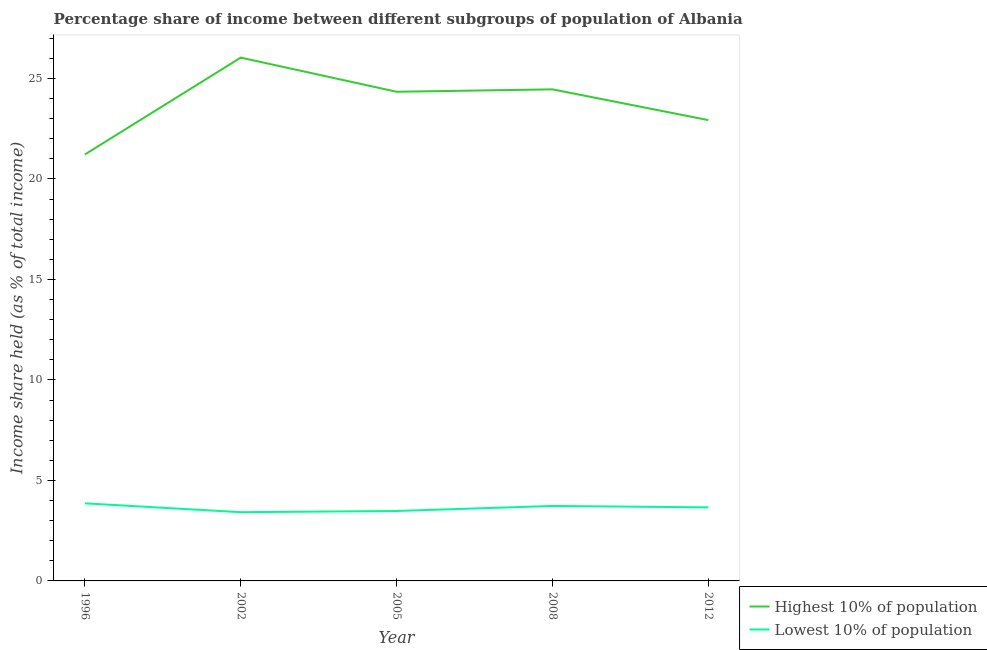How many different coloured lines are there?
Ensure brevity in your answer.  2. Is the number of lines equal to the number of legend labels?
Your response must be concise. Yes. What is the income share held by highest 10% of the population in 1996?
Provide a succinct answer. 21.22. Across all years, what is the maximum income share held by lowest 10% of the population?
Your answer should be very brief. 3.86. Across all years, what is the minimum income share held by highest 10% of the population?
Your answer should be compact. 21.22. What is the total income share held by highest 10% of the population in the graph?
Make the answer very short. 118.99. What is the difference between the income share held by lowest 10% of the population in 1996 and that in 2002?
Your answer should be compact. 0.44. What is the difference between the income share held by highest 10% of the population in 2008 and the income share held by lowest 10% of the population in 2002?
Make the answer very short. 21.04. What is the average income share held by highest 10% of the population per year?
Give a very brief answer. 23.8. In the year 2002, what is the difference between the income share held by highest 10% of the population and income share held by lowest 10% of the population?
Your answer should be very brief. 22.62. What is the ratio of the income share held by lowest 10% of the population in 1996 to that in 2005?
Make the answer very short. 1.11. Is the difference between the income share held by lowest 10% of the population in 1996 and 2012 greater than the difference between the income share held by highest 10% of the population in 1996 and 2012?
Your response must be concise. Yes. What is the difference between the highest and the second highest income share held by highest 10% of the population?
Your response must be concise. 1.58. What is the difference between the highest and the lowest income share held by lowest 10% of the population?
Make the answer very short. 0.44. In how many years, is the income share held by highest 10% of the population greater than the average income share held by highest 10% of the population taken over all years?
Offer a very short reply. 3. Does the income share held by lowest 10% of the population monotonically increase over the years?
Your response must be concise. No. Is the income share held by lowest 10% of the population strictly greater than the income share held by highest 10% of the population over the years?
Your response must be concise. No. How many lines are there?
Provide a short and direct response. 2. How many years are there in the graph?
Offer a very short reply. 5. Does the graph contain any zero values?
Your answer should be compact. No. Does the graph contain grids?
Give a very brief answer. No. How many legend labels are there?
Keep it short and to the point. 2. What is the title of the graph?
Keep it short and to the point. Percentage share of income between different subgroups of population of Albania. Does "Primary school" appear as one of the legend labels in the graph?
Offer a very short reply. No. What is the label or title of the X-axis?
Your answer should be compact. Year. What is the label or title of the Y-axis?
Your answer should be compact. Income share held (as % of total income). What is the Income share held (as % of total income) in Highest 10% of population in 1996?
Offer a very short reply. 21.22. What is the Income share held (as % of total income) in Lowest 10% of population in 1996?
Offer a terse response. 3.86. What is the Income share held (as % of total income) of Highest 10% of population in 2002?
Provide a succinct answer. 26.04. What is the Income share held (as % of total income) of Lowest 10% of population in 2002?
Provide a short and direct response. 3.42. What is the Income share held (as % of total income) of Highest 10% of population in 2005?
Provide a succinct answer. 24.34. What is the Income share held (as % of total income) in Lowest 10% of population in 2005?
Provide a succinct answer. 3.48. What is the Income share held (as % of total income) of Highest 10% of population in 2008?
Provide a succinct answer. 24.46. What is the Income share held (as % of total income) in Lowest 10% of population in 2008?
Give a very brief answer. 3.73. What is the Income share held (as % of total income) in Highest 10% of population in 2012?
Your answer should be compact. 22.93. What is the Income share held (as % of total income) in Lowest 10% of population in 2012?
Keep it short and to the point. 3.66. Across all years, what is the maximum Income share held (as % of total income) in Highest 10% of population?
Your answer should be very brief. 26.04. Across all years, what is the maximum Income share held (as % of total income) of Lowest 10% of population?
Provide a short and direct response. 3.86. Across all years, what is the minimum Income share held (as % of total income) of Highest 10% of population?
Keep it short and to the point. 21.22. Across all years, what is the minimum Income share held (as % of total income) in Lowest 10% of population?
Provide a short and direct response. 3.42. What is the total Income share held (as % of total income) of Highest 10% of population in the graph?
Your response must be concise. 118.99. What is the total Income share held (as % of total income) in Lowest 10% of population in the graph?
Make the answer very short. 18.15. What is the difference between the Income share held (as % of total income) in Highest 10% of population in 1996 and that in 2002?
Make the answer very short. -4.82. What is the difference between the Income share held (as % of total income) of Lowest 10% of population in 1996 and that in 2002?
Provide a succinct answer. 0.44. What is the difference between the Income share held (as % of total income) in Highest 10% of population in 1996 and that in 2005?
Your answer should be very brief. -3.12. What is the difference between the Income share held (as % of total income) of Lowest 10% of population in 1996 and that in 2005?
Make the answer very short. 0.38. What is the difference between the Income share held (as % of total income) of Highest 10% of population in 1996 and that in 2008?
Make the answer very short. -3.24. What is the difference between the Income share held (as % of total income) in Lowest 10% of population in 1996 and that in 2008?
Provide a succinct answer. 0.13. What is the difference between the Income share held (as % of total income) in Highest 10% of population in 1996 and that in 2012?
Offer a terse response. -1.71. What is the difference between the Income share held (as % of total income) of Lowest 10% of population in 1996 and that in 2012?
Provide a succinct answer. 0.2. What is the difference between the Income share held (as % of total income) of Lowest 10% of population in 2002 and that in 2005?
Provide a short and direct response. -0.06. What is the difference between the Income share held (as % of total income) of Highest 10% of population in 2002 and that in 2008?
Your answer should be very brief. 1.58. What is the difference between the Income share held (as % of total income) in Lowest 10% of population in 2002 and that in 2008?
Give a very brief answer. -0.31. What is the difference between the Income share held (as % of total income) of Highest 10% of population in 2002 and that in 2012?
Give a very brief answer. 3.11. What is the difference between the Income share held (as % of total income) in Lowest 10% of population in 2002 and that in 2012?
Make the answer very short. -0.24. What is the difference between the Income share held (as % of total income) in Highest 10% of population in 2005 and that in 2008?
Your answer should be very brief. -0.12. What is the difference between the Income share held (as % of total income) of Highest 10% of population in 2005 and that in 2012?
Offer a terse response. 1.41. What is the difference between the Income share held (as % of total income) in Lowest 10% of population in 2005 and that in 2012?
Give a very brief answer. -0.18. What is the difference between the Income share held (as % of total income) in Highest 10% of population in 2008 and that in 2012?
Provide a short and direct response. 1.53. What is the difference between the Income share held (as % of total income) in Lowest 10% of population in 2008 and that in 2012?
Provide a short and direct response. 0.07. What is the difference between the Income share held (as % of total income) in Highest 10% of population in 1996 and the Income share held (as % of total income) in Lowest 10% of population in 2005?
Offer a very short reply. 17.74. What is the difference between the Income share held (as % of total income) of Highest 10% of population in 1996 and the Income share held (as % of total income) of Lowest 10% of population in 2008?
Make the answer very short. 17.49. What is the difference between the Income share held (as % of total income) of Highest 10% of population in 1996 and the Income share held (as % of total income) of Lowest 10% of population in 2012?
Your answer should be very brief. 17.56. What is the difference between the Income share held (as % of total income) of Highest 10% of population in 2002 and the Income share held (as % of total income) of Lowest 10% of population in 2005?
Offer a very short reply. 22.56. What is the difference between the Income share held (as % of total income) of Highest 10% of population in 2002 and the Income share held (as % of total income) of Lowest 10% of population in 2008?
Your answer should be very brief. 22.31. What is the difference between the Income share held (as % of total income) in Highest 10% of population in 2002 and the Income share held (as % of total income) in Lowest 10% of population in 2012?
Provide a succinct answer. 22.38. What is the difference between the Income share held (as % of total income) in Highest 10% of population in 2005 and the Income share held (as % of total income) in Lowest 10% of population in 2008?
Make the answer very short. 20.61. What is the difference between the Income share held (as % of total income) in Highest 10% of population in 2005 and the Income share held (as % of total income) in Lowest 10% of population in 2012?
Provide a short and direct response. 20.68. What is the difference between the Income share held (as % of total income) in Highest 10% of population in 2008 and the Income share held (as % of total income) in Lowest 10% of population in 2012?
Offer a terse response. 20.8. What is the average Income share held (as % of total income) in Highest 10% of population per year?
Your answer should be very brief. 23.8. What is the average Income share held (as % of total income) in Lowest 10% of population per year?
Make the answer very short. 3.63. In the year 1996, what is the difference between the Income share held (as % of total income) in Highest 10% of population and Income share held (as % of total income) in Lowest 10% of population?
Offer a terse response. 17.36. In the year 2002, what is the difference between the Income share held (as % of total income) in Highest 10% of population and Income share held (as % of total income) in Lowest 10% of population?
Your answer should be very brief. 22.62. In the year 2005, what is the difference between the Income share held (as % of total income) of Highest 10% of population and Income share held (as % of total income) of Lowest 10% of population?
Offer a terse response. 20.86. In the year 2008, what is the difference between the Income share held (as % of total income) in Highest 10% of population and Income share held (as % of total income) in Lowest 10% of population?
Keep it short and to the point. 20.73. In the year 2012, what is the difference between the Income share held (as % of total income) in Highest 10% of population and Income share held (as % of total income) in Lowest 10% of population?
Your answer should be very brief. 19.27. What is the ratio of the Income share held (as % of total income) in Highest 10% of population in 1996 to that in 2002?
Your response must be concise. 0.81. What is the ratio of the Income share held (as % of total income) of Lowest 10% of population in 1996 to that in 2002?
Provide a succinct answer. 1.13. What is the ratio of the Income share held (as % of total income) in Highest 10% of population in 1996 to that in 2005?
Your response must be concise. 0.87. What is the ratio of the Income share held (as % of total income) of Lowest 10% of population in 1996 to that in 2005?
Your response must be concise. 1.11. What is the ratio of the Income share held (as % of total income) of Highest 10% of population in 1996 to that in 2008?
Provide a short and direct response. 0.87. What is the ratio of the Income share held (as % of total income) in Lowest 10% of population in 1996 to that in 2008?
Your response must be concise. 1.03. What is the ratio of the Income share held (as % of total income) of Highest 10% of population in 1996 to that in 2012?
Ensure brevity in your answer.  0.93. What is the ratio of the Income share held (as % of total income) in Lowest 10% of population in 1996 to that in 2012?
Give a very brief answer. 1.05. What is the ratio of the Income share held (as % of total income) of Highest 10% of population in 2002 to that in 2005?
Offer a terse response. 1.07. What is the ratio of the Income share held (as % of total income) of Lowest 10% of population in 2002 to that in 2005?
Make the answer very short. 0.98. What is the ratio of the Income share held (as % of total income) of Highest 10% of population in 2002 to that in 2008?
Keep it short and to the point. 1.06. What is the ratio of the Income share held (as % of total income) in Lowest 10% of population in 2002 to that in 2008?
Provide a succinct answer. 0.92. What is the ratio of the Income share held (as % of total income) in Highest 10% of population in 2002 to that in 2012?
Your response must be concise. 1.14. What is the ratio of the Income share held (as % of total income) of Lowest 10% of population in 2002 to that in 2012?
Offer a very short reply. 0.93. What is the ratio of the Income share held (as % of total income) of Highest 10% of population in 2005 to that in 2008?
Ensure brevity in your answer.  1. What is the ratio of the Income share held (as % of total income) of Lowest 10% of population in 2005 to that in 2008?
Provide a succinct answer. 0.93. What is the ratio of the Income share held (as % of total income) in Highest 10% of population in 2005 to that in 2012?
Your response must be concise. 1.06. What is the ratio of the Income share held (as % of total income) in Lowest 10% of population in 2005 to that in 2012?
Offer a terse response. 0.95. What is the ratio of the Income share held (as % of total income) in Highest 10% of population in 2008 to that in 2012?
Your answer should be very brief. 1.07. What is the ratio of the Income share held (as % of total income) in Lowest 10% of population in 2008 to that in 2012?
Your answer should be very brief. 1.02. What is the difference between the highest and the second highest Income share held (as % of total income) in Highest 10% of population?
Your answer should be compact. 1.58. What is the difference between the highest and the second highest Income share held (as % of total income) of Lowest 10% of population?
Ensure brevity in your answer.  0.13. What is the difference between the highest and the lowest Income share held (as % of total income) of Highest 10% of population?
Your response must be concise. 4.82. What is the difference between the highest and the lowest Income share held (as % of total income) of Lowest 10% of population?
Offer a terse response. 0.44. 